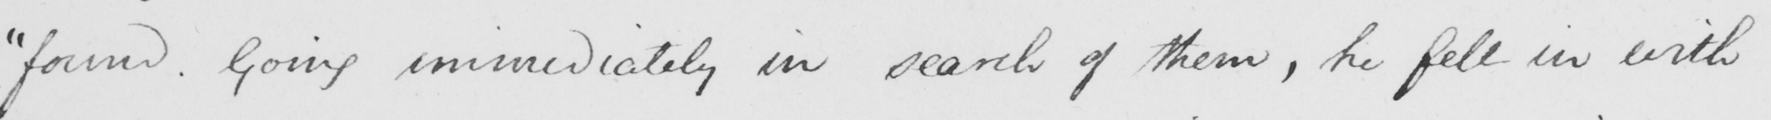What text is written in this handwritten line? " found . Going immediately in search of them , he fell in with 